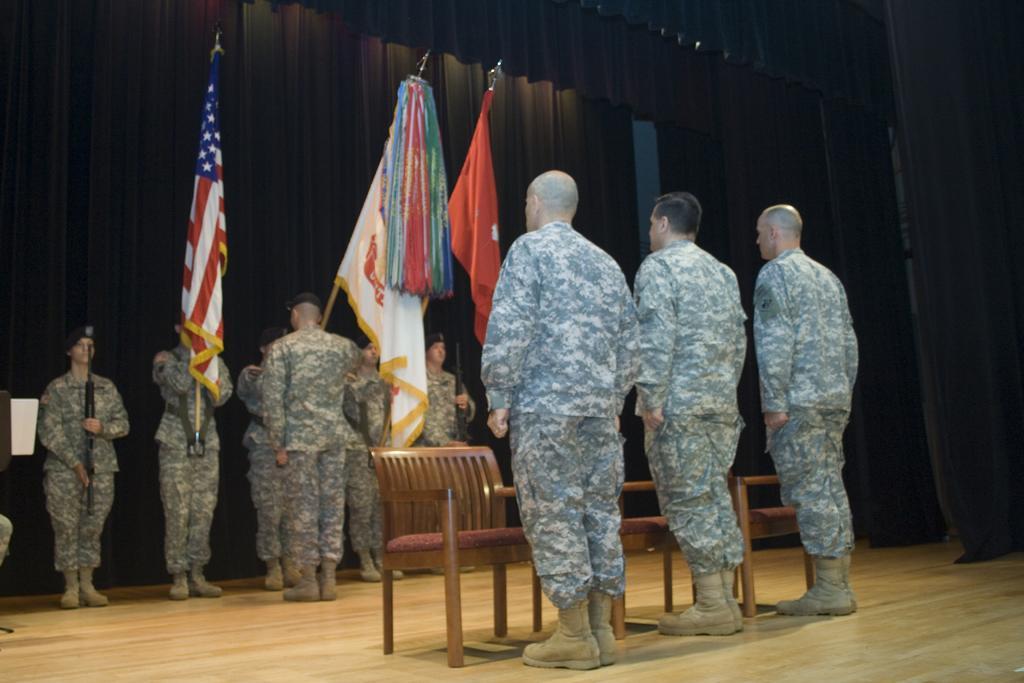Could you give a brief overview of what you see in this image? In this picture we can see groups of people and chairs on the wooden floor. There are some people holding sticks with flags. Behind the people, those are looking like curtains. On the left side of the image, there is an object. 